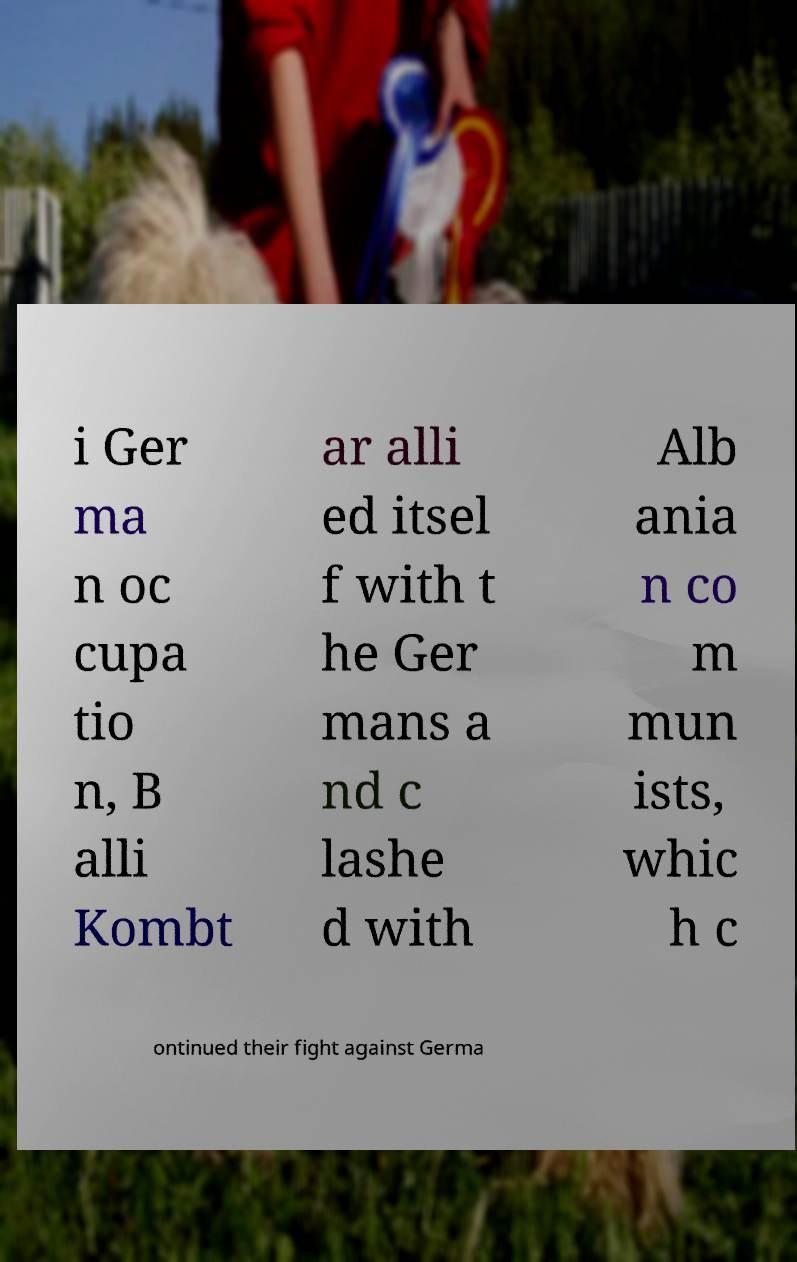What messages or text are displayed in this image? I need them in a readable, typed format. i Ger ma n oc cupa tio n, B alli Kombt ar alli ed itsel f with t he Ger mans a nd c lashe d with Alb ania n co m mun ists, whic h c ontinued their fight against Germa 